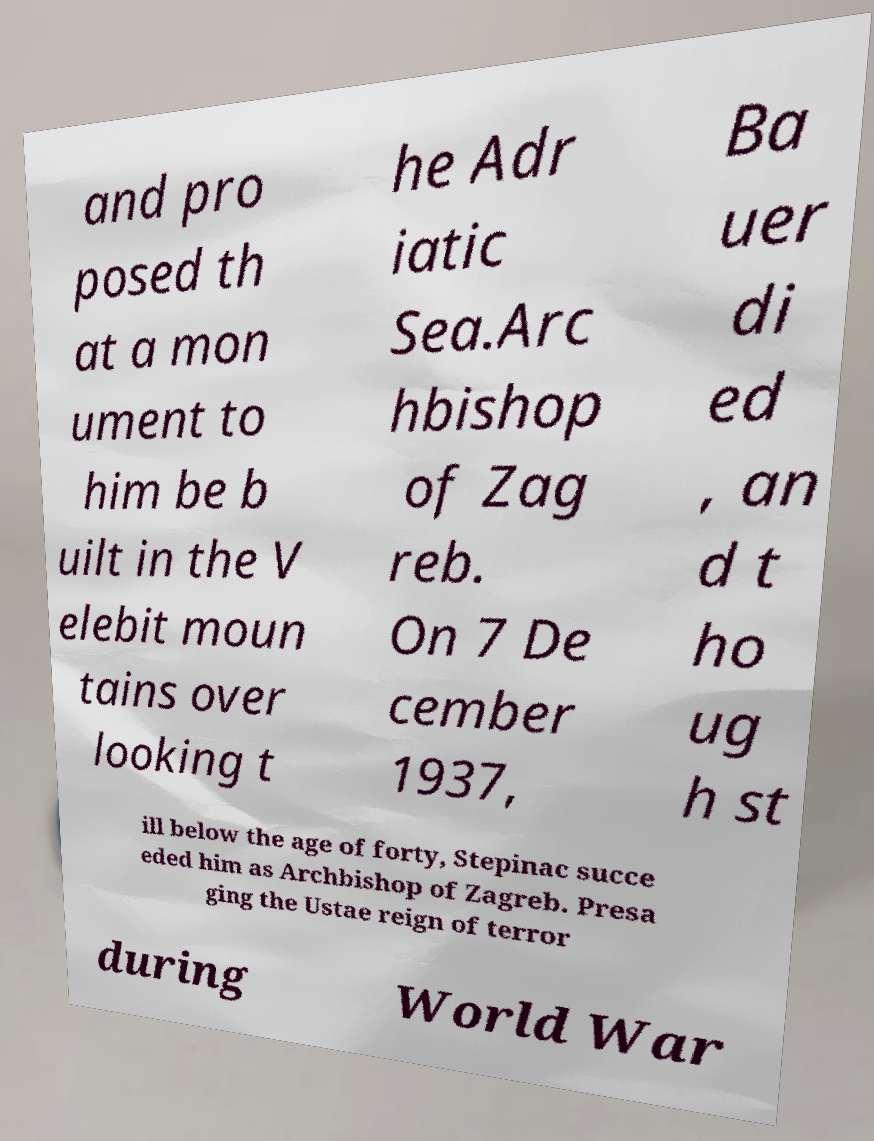Please read and relay the text visible in this image. What does it say? and pro posed th at a mon ument to him be b uilt in the V elebit moun tains over looking t he Adr iatic Sea.Arc hbishop of Zag reb. On 7 De cember 1937, Ba uer di ed , an d t ho ug h st ill below the age of forty, Stepinac succe eded him as Archbishop of Zagreb. Presa ging the Ustae reign of terror during World War 